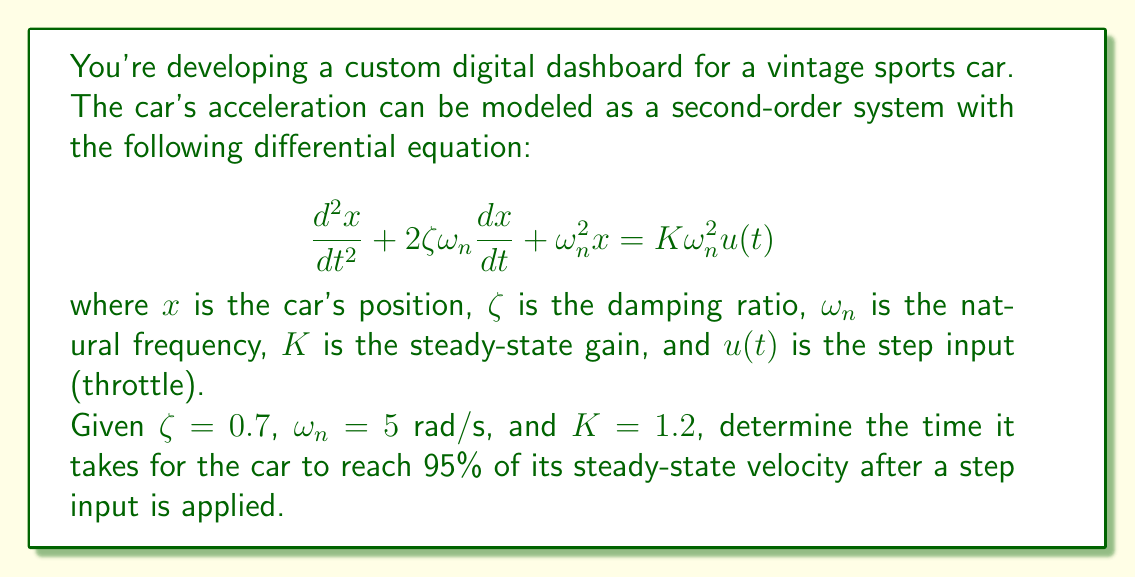Show me your answer to this math problem. To solve this problem, we need to follow these steps:

1) First, recall that for a second-order system, the rise time (time to reach 95% of steady-state value) for velocity is approximately:

   $$t_r \approx \frac{1.8}{\zeta\omega_n}$$

2) We're given $\zeta = 0.7$ and $\omega_n = 5$ rad/s. Let's substitute these values:

   $$t_r \approx \frac{1.8}{0.7 \cdot 5}$$

3) Now, let's calculate:

   $$t_r \approx \frac{1.8}{3.5} = 0.5143$$

4) Therefore, the time it takes for the car to reach 95% of its steady-state velocity is approximately 0.5143 seconds.

Note: The steady-state gain $K$ doesn't affect the rise time, so we don't need to use it in this calculation. It would, however, affect the final steady-state velocity.
Answer: $t_r \approx 0.5143$ seconds 